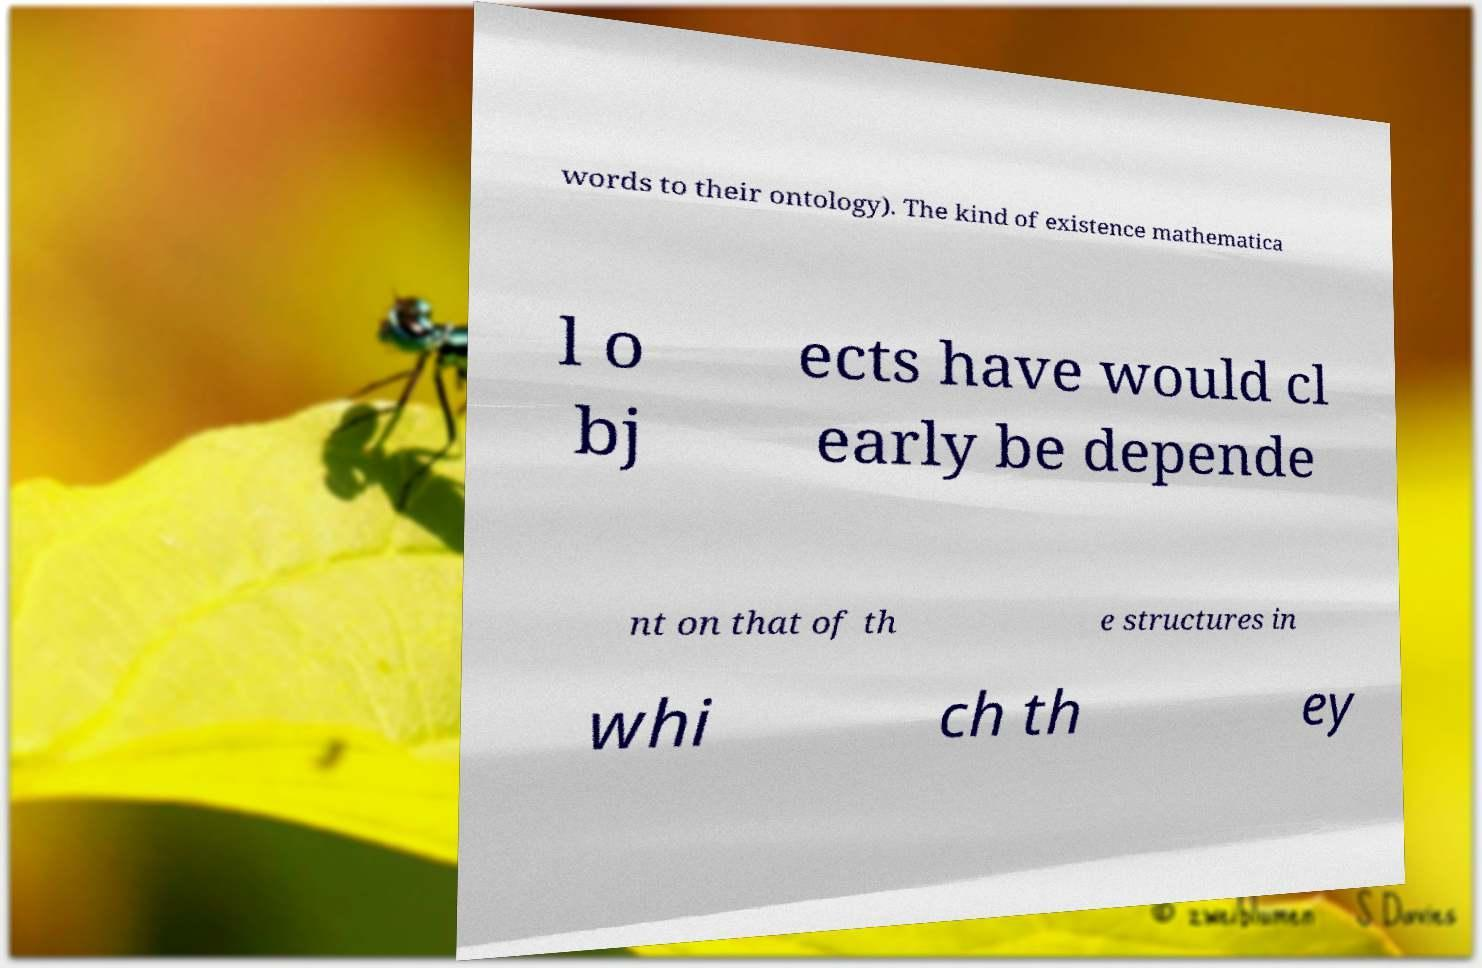Can you read and provide the text displayed in the image?This photo seems to have some interesting text. Can you extract and type it out for me? words to their ontology). The kind of existence mathematica l o bj ects have would cl early be depende nt on that of th e structures in whi ch th ey 